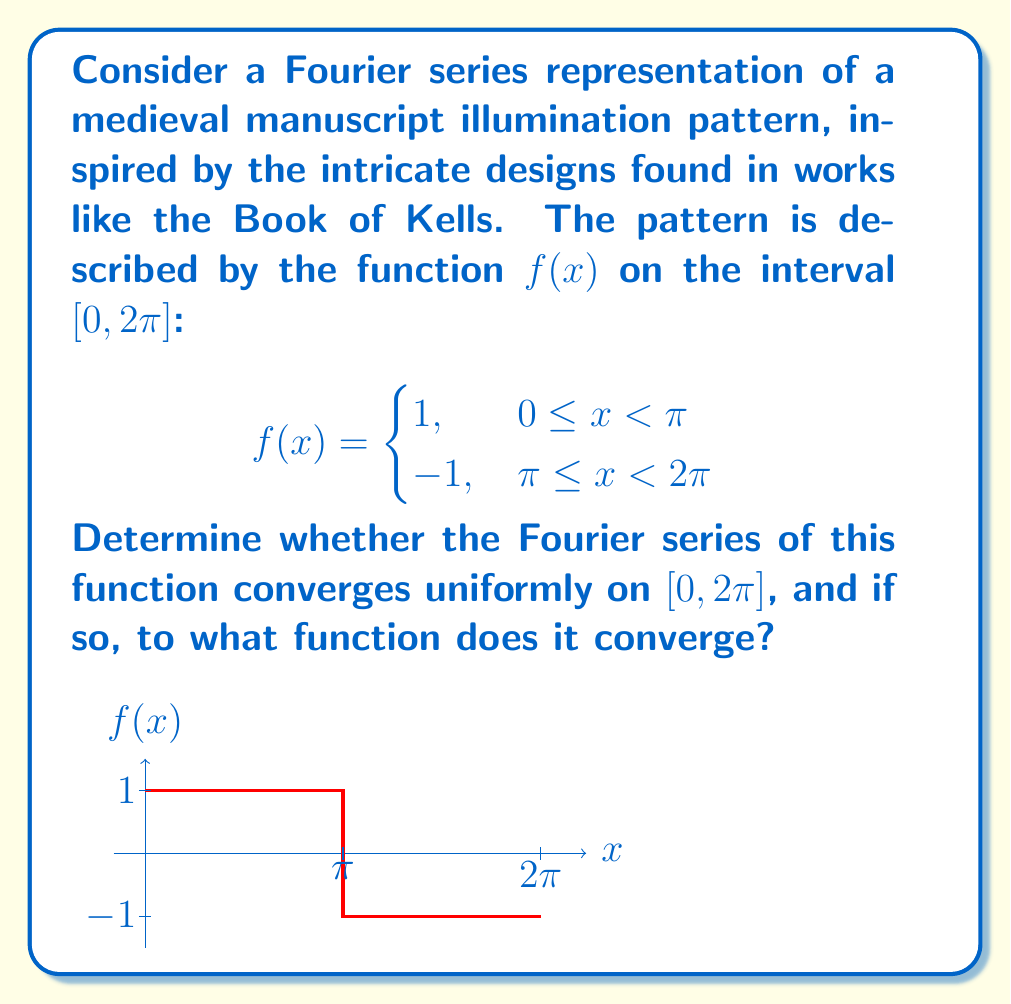Can you solve this math problem? To analyze the convergence of this Fourier series, we'll follow these steps:

1) First, recall that the Fourier series for a function $f(x)$ on $[0, 2\pi]$ is given by:

   $$S_n(x) = \frac{a_0}{2} + \sum_{k=1}^n (a_k \cos(kx) + b_k \sin(kx))$$

   where $a_k$ and $b_k$ are the Fourier coefficients.

2) For our function $f(x)$, due to its odd symmetry around $x = \pi$, all cosine terms will vanish (i.e., $a_k = 0$ for all $k$). We only need to consider sine terms.

3) The Fourier coefficients $b_k$ are given by:

   $$b_k = \frac{1}{\pi} \int_0^{2\pi} f(x) \sin(kx) dx$$

4) Calculating $b_k$:
   
   $$b_k = \frac{1}{\pi} \left(\int_0^{\pi} \sin(kx) dx - \int_{\pi}^{2\pi} \sin(kx) dx\right)$$
   
   $$= \frac{1}{\pi} \left(-\frac{1}{k}\cos(kx)\bigg|_0^{\pi} + \frac{1}{k}\cos(kx)\bigg|_{\pi}^{2\pi}\right)$$
   
   $$= \frac{2}{\pi k}(1 - \cos(k\pi)) = \begin{cases}
   \frac{4}{\pi k}, & k \text{ odd} \\
   0, & k \text{ even}
   \end{cases}$$

5) Thus, our Fourier series becomes:

   $$S(x) = \frac{4}{\pi} \sum_{k \text{ odd}} \frac{1}{k} \sin(kx)$$

6) To determine uniform convergence, we need to examine the behavior of the partial sums. The difference between $f(x)$ and $S_n(x)$ at the discontinuity ($x = \pi$) is known as the Gibbs phenomenon. The overshoot at this point does not vanish as $n \to \infty$.

7) Therefore, the series does not converge uniformly on $[0, 2\pi]$. However, it does converge pointwise to $f(x)$ at all points except at $x = \pi$, where it converges to the average of the left and right limits: 0.

8) The function to which the series converges is:

   $$g(x) = \begin{cases}
   1, & 0 \leq x < \pi \\
   0, & x = \pi \\
   -1, & \pi < x < 2\pi
   \end{cases}$$
Answer: The Fourier series converges pointwise to $f(x)$ except at $x = \pi$, where it converges to 0. It does not converge uniformly on $[0, 2\pi]$. 